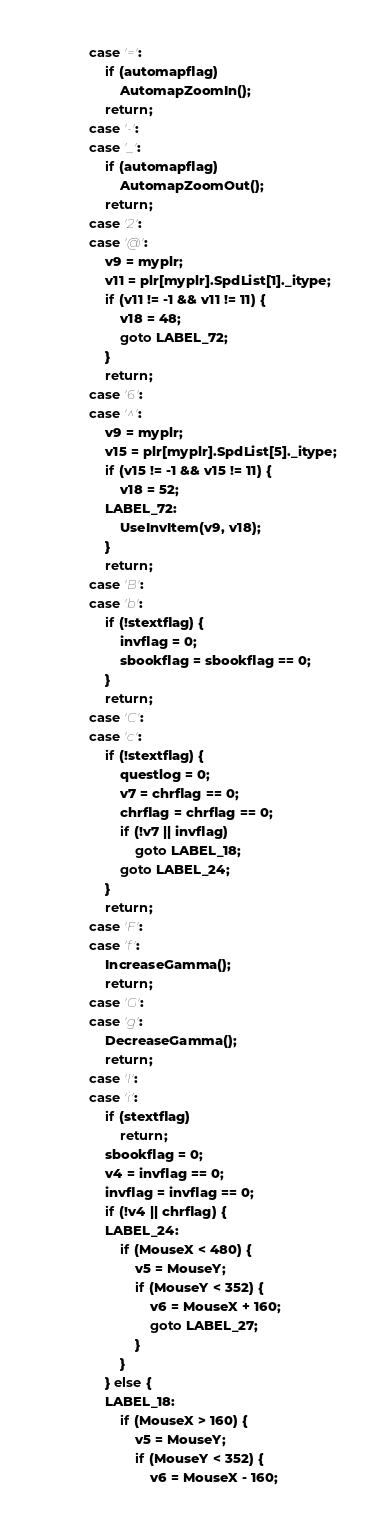Convert code to text. <code><loc_0><loc_0><loc_500><loc_500><_C++_>			case '=':
				if (automapflag)
					AutomapZoomIn();
				return;
			case '-':
			case '_':
				if (automapflag)
					AutomapZoomOut();
				return;
			case '2':
			case '@':
				v9 = myplr;
				v11 = plr[myplr].SpdList[1]._itype;
				if (v11 != -1 && v11 != 11) {
					v18 = 48;
					goto LABEL_72;
				}
				return;
			case '6':
			case '^':
				v9 = myplr;
				v15 = plr[myplr].SpdList[5]._itype;
				if (v15 != -1 && v15 != 11) {
					v18 = 52;
				LABEL_72:
					UseInvItem(v9, v18);
				}
				return;
			case 'B':
			case 'b':
				if (!stextflag) {
					invflag = 0;
					sbookflag = sbookflag == 0;
				}
				return;
			case 'C':
			case 'c':
				if (!stextflag) {
					questlog = 0;
					v7 = chrflag == 0;
					chrflag = chrflag == 0;
					if (!v7 || invflag)
						goto LABEL_18;
					goto LABEL_24;
				}
				return;
			case 'F':
			case 'f':
				IncreaseGamma();
				return;
			case 'G':
			case 'g':
				DecreaseGamma();
				return;
			case 'I':
			case 'i':
				if (stextflag)
					return;
				sbookflag = 0;
				v4 = invflag == 0;
				invflag = invflag == 0;
				if (!v4 || chrflag) {
				LABEL_24:
					if (MouseX < 480) {
						v5 = MouseY;
						if (MouseY < 352) {
							v6 = MouseX + 160;
							goto LABEL_27;
						}
					}
				} else {
				LABEL_18:
					if (MouseX > 160) {
						v5 = MouseY;
						if (MouseY < 352) {
							v6 = MouseX - 160;</code> 